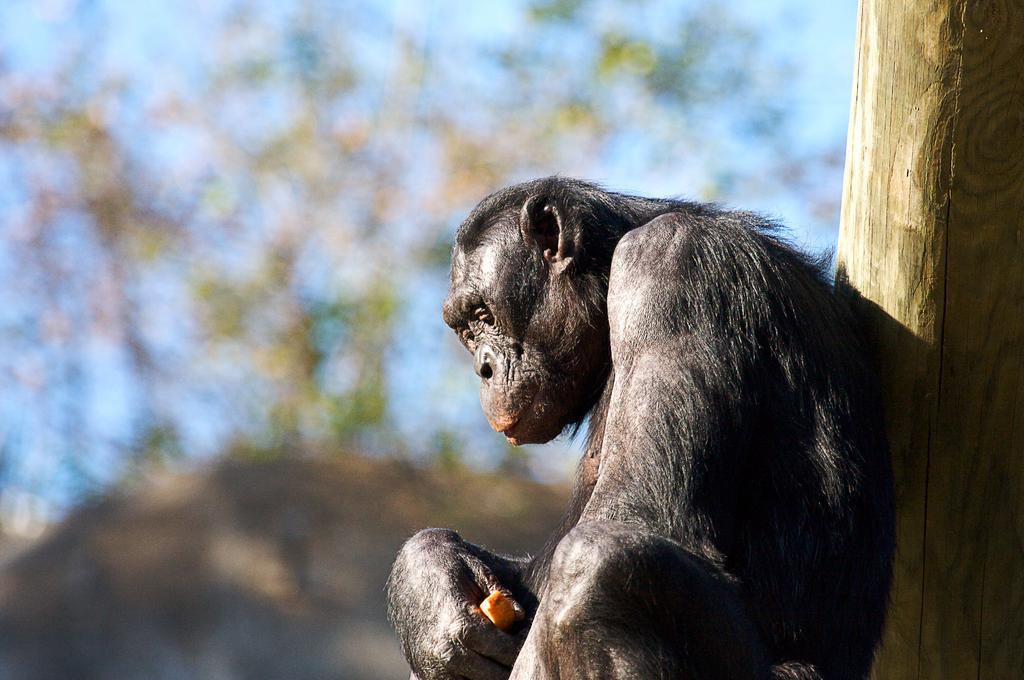Can you describe this image briefly? In this picture there is a chimpanzee in the center of the image and there is a bamboo on the right side of the image, the background area of the image. 